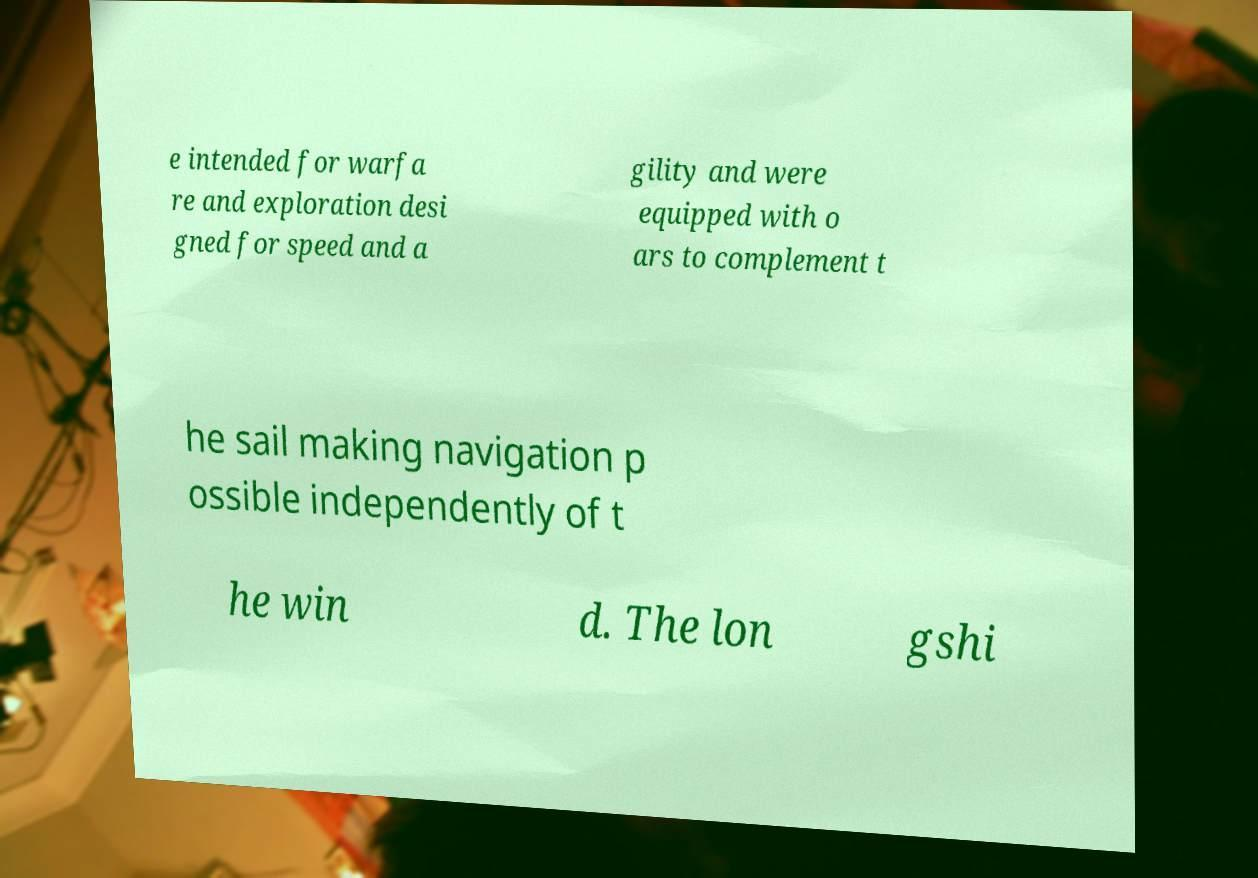Can you accurately transcribe the text from the provided image for me? e intended for warfa re and exploration desi gned for speed and a gility and were equipped with o ars to complement t he sail making navigation p ossible independently of t he win d. The lon gshi 